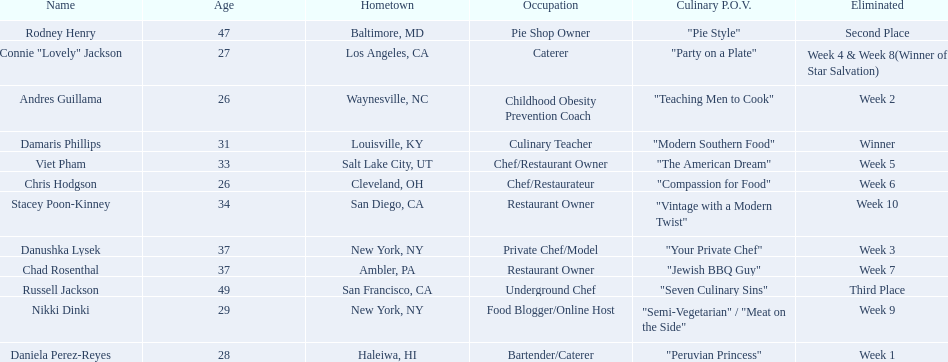Who where the people in the food network? Damaris Phillips, Rodney Henry, Russell Jackson, Stacey Poon-Kinney, Nikki Dinki, Chad Rosenthal, Chris Hodgson, Viet Pham, Connie "Lovely" Jackson, Danushka Lysek, Andres Guillama, Daniela Perez-Reyes. When was nikki dinki eliminated? Week 9. When was viet pham eliminated? Week 5. Which of these two is earlier? Week 5. Who was eliminated in this week? Viet Pham. 